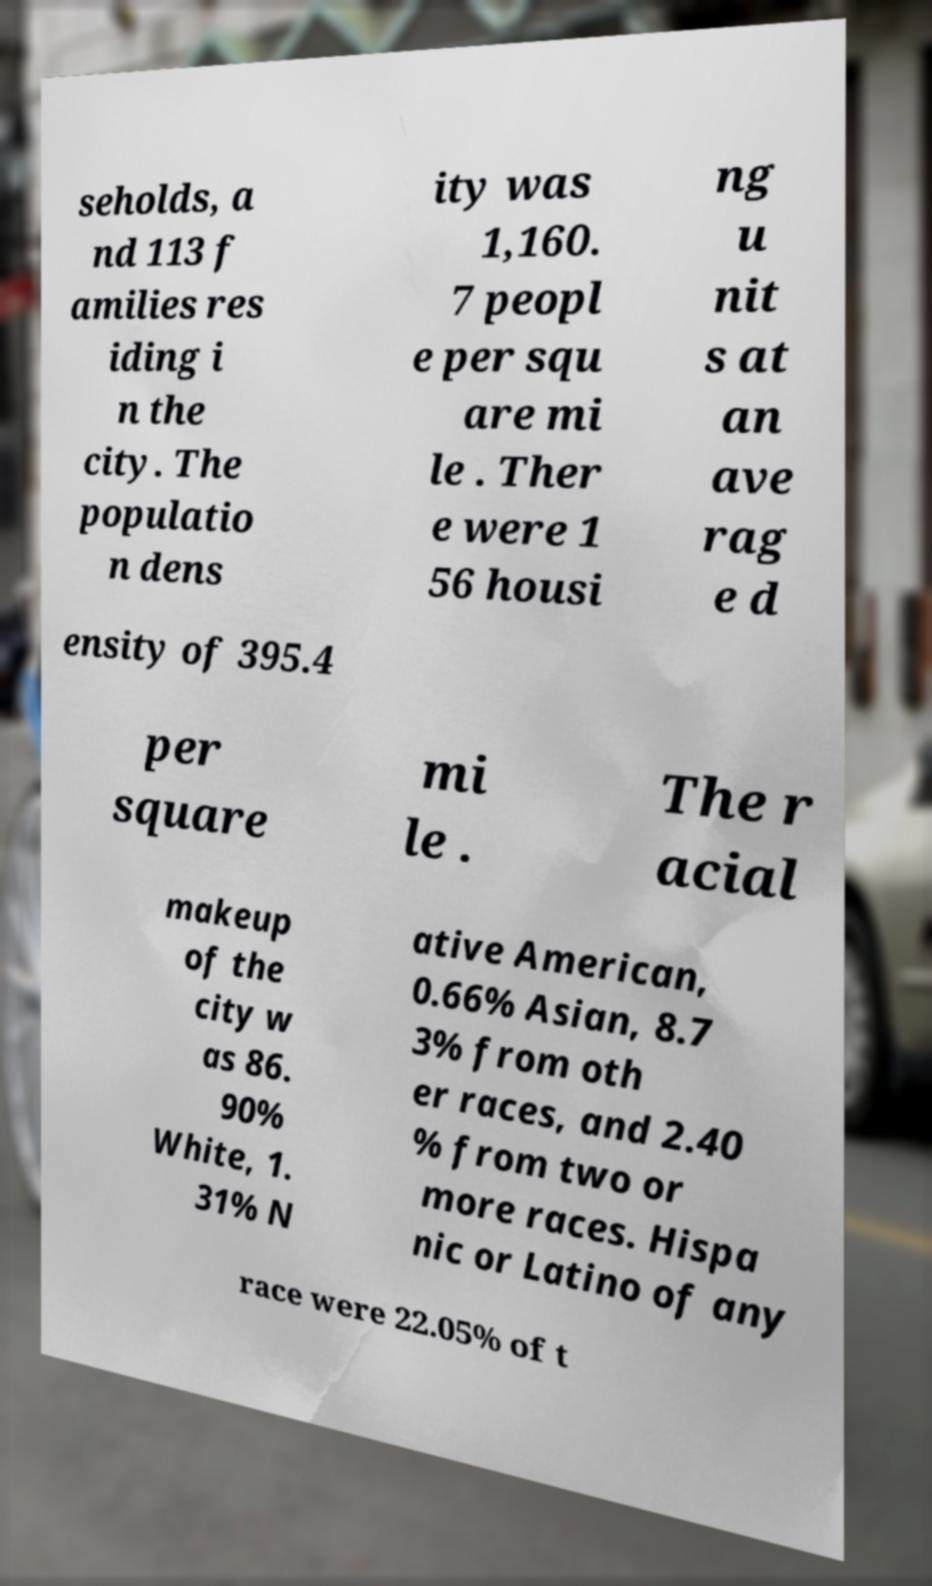Can you read and provide the text displayed in the image?This photo seems to have some interesting text. Can you extract and type it out for me? seholds, a nd 113 f amilies res iding i n the city. The populatio n dens ity was 1,160. 7 peopl e per squ are mi le . Ther e were 1 56 housi ng u nit s at an ave rag e d ensity of 395.4 per square mi le . The r acial makeup of the city w as 86. 90% White, 1. 31% N ative American, 0.66% Asian, 8.7 3% from oth er races, and 2.40 % from two or more races. Hispa nic or Latino of any race were 22.05% of t 